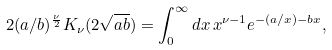Convert formula to latex. <formula><loc_0><loc_0><loc_500><loc_500>2 ( a / b ) ^ { \frac { \nu } { 2 } } K _ { \nu } ( 2 \sqrt { a b } ) = \int _ { 0 } ^ { \infty } d x \, x ^ { \nu - 1 } e ^ { - ( a / x ) - b x } ,</formula> 